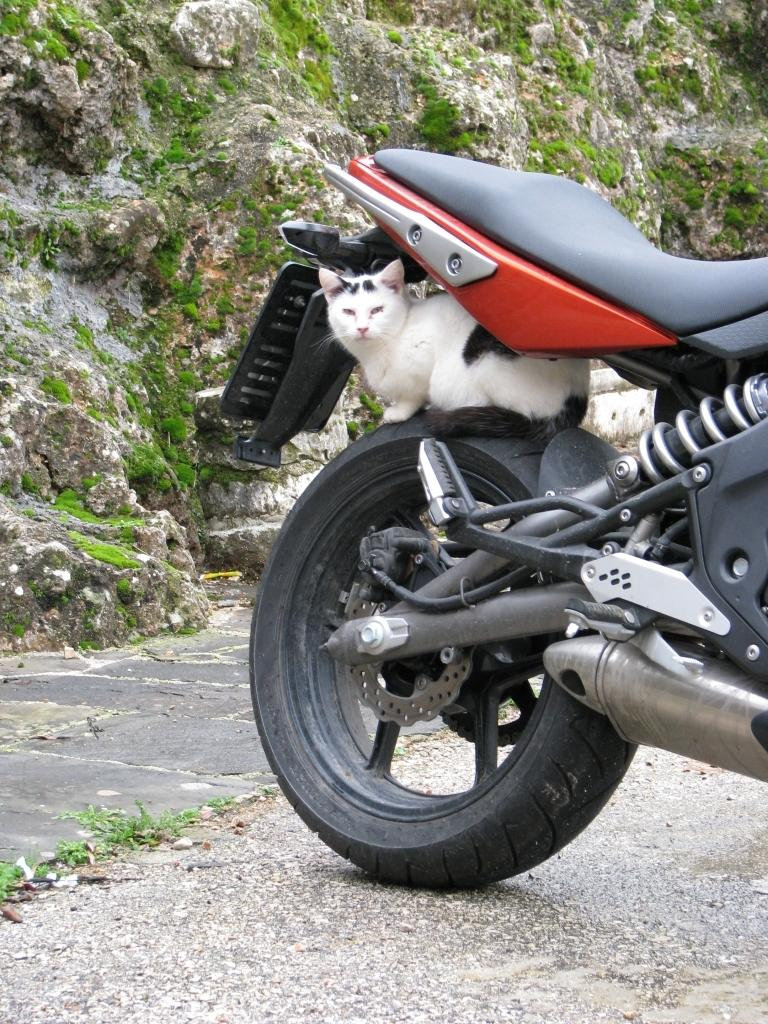What is the main object in the image? There is a bike in the image. What is the current state of the bike? The bike is parked. Are there any animals present in the image? Yes, there is a cat sitting near the bike. What can be seen in the background of the image? There is a hill visible in the background of the image, and there is grass on the hill. How many eggs are being carried by the crook in the image? There is no crook or eggs present in the image. What type of soda is being served at the picnic in the image? There is no picnic or soda present in the image. 